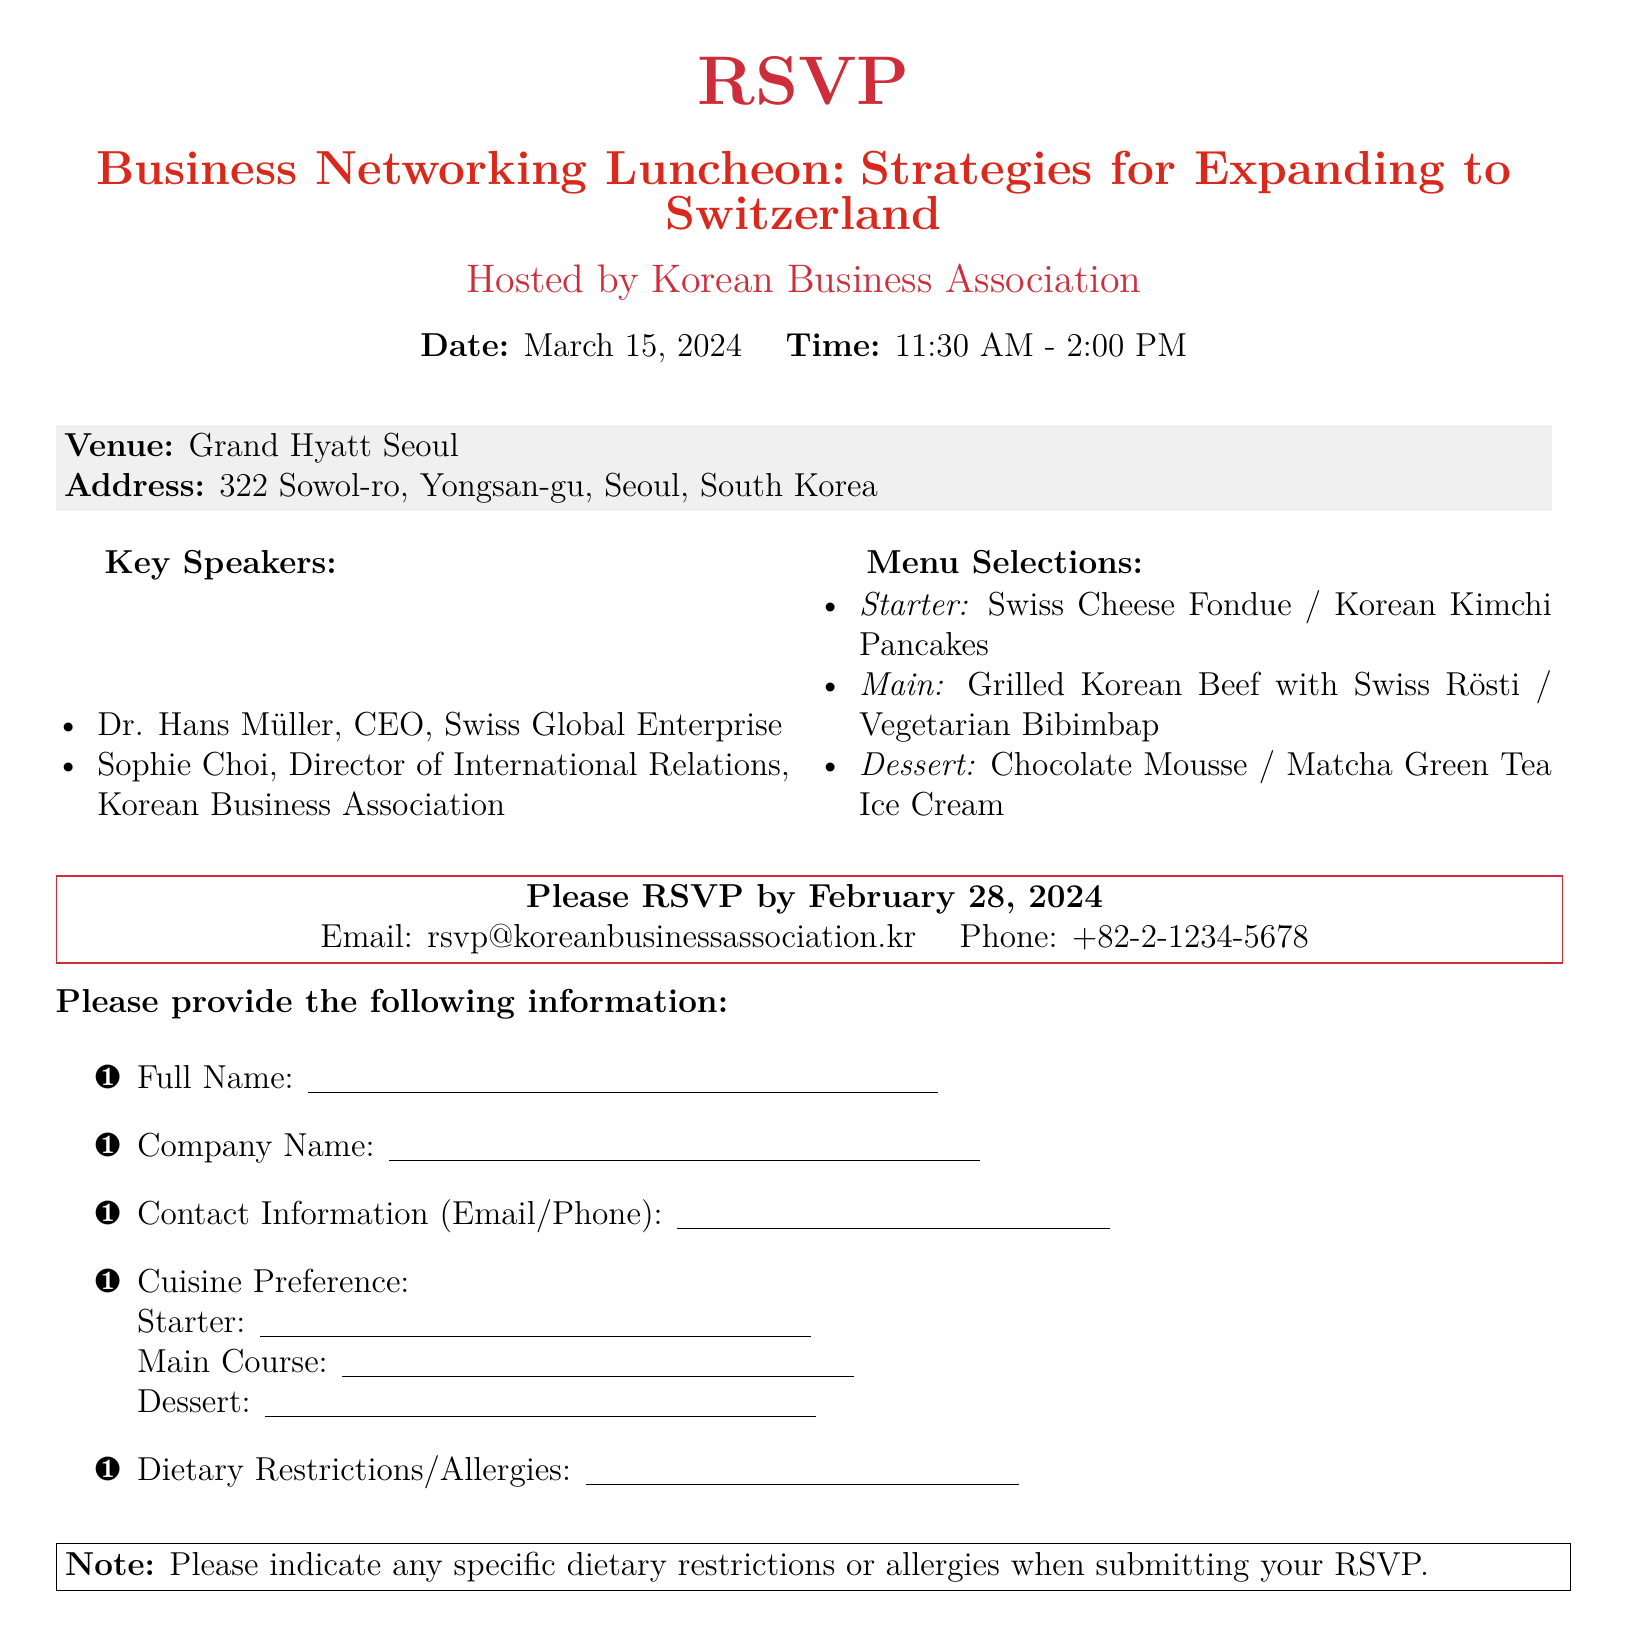what is the date of the luncheon? The date of the luncheon is explicitly mentioned in the document.
Answer: March 15, 2024 what time does the luncheon start? The starting time is provided in the event details of the document.
Answer: 11:30 AM who is one of the key speakers? The names of the key speakers are listed in the document.
Answer: Dr. Hans Müller what is the address of the venue? The venue address is provided in the details section of the document.
Answer: 322 Sowol-ro, Yongsan-gu, Seoul, South Korea what is one of the menu selections for the main course? The document lists various menu options under the menu selections section.
Answer: Grilled Korean Beef with Swiss Rösti how should I submit my RSVP? The RSVP submission instructions are outlined at the bottom of the document.
Answer: Email: rsvp@koreanbusinessassociation.kr what is the RSVP deadline? The deadline for RSVPs is stated in the document.
Answer: February 28, 2024 what type of dietary information should I provide? The document specifies the type of dietary information requested from attendees.
Answer: Dietary Restrictions/Allergies how many speakers are mentioned in the document? The total number of key speakers is clearly indicated in the list of speakers.
Answer: 2 